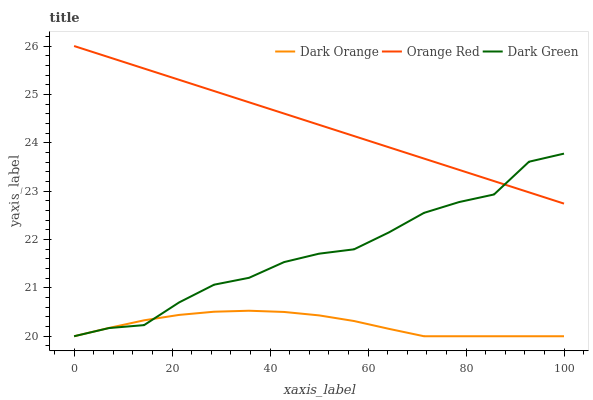Does Dark Orange have the minimum area under the curve?
Answer yes or no. Yes. Does Orange Red have the maximum area under the curve?
Answer yes or no. Yes. Does Dark Green have the minimum area under the curve?
Answer yes or no. No. Does Dark Green have the maximum area under the curve?
Answer yes or no. No. Is Orange Red the smoothest?
Answer yes or no. Yes. Is Dark Green the roughest?
Answer yes or no. Yes. Is Dark Green the smoothest?
Answer yes or no. No. Is Orange Red the roughest?
Answer yes or no. No. Does Dark Orange have the lowest value?
Answer yes or no. Yes. Does Orange Red have the lowest value?
Answer yes or no. No. Does Orange Red have the highest value?
Answer yes or no. Yes. Does Dark Green have the highest value?
Answer yes or no. No. Is Dark Orange less than Orange Red?
Answer yes or no. Yes. Is Orange Red greater than Dark Orange?
Answer yes or no. Yes. Does Dark Green intersect Dark Orange?
Answer yes or no. Yes. Is Dark Green less than Dark Orange?
Answer yes or no. No. Is Dark Green greater than Dark Orange?
Answer yes or no. No. Does Dark Orange intersect Orange Red?
Answer yes or no. No. 